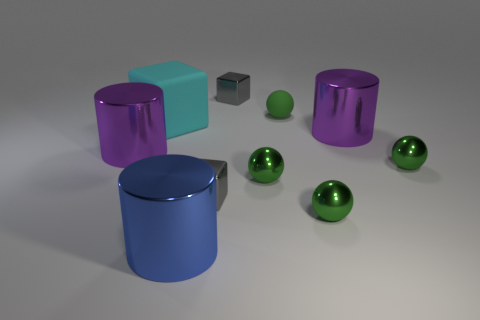How many other things are there of the same color as the tiny rubber object?
Provide a short and direct response. 3. There is a metal thing that is behind the small rubber ball; what is its color?
Provide a succinct answer. Gray. How big is the cylinder that is behind the blue metallic object and on the left side of the green rubber ball?
Make the answer very short. Large. Does the big cyan object have the same material as the tiny gray cube behind the cyan thing?
Keep it short and to the point. No. What number of small gray things are the same shape as the cyan object?
Give a very brief answer. 2. What number of tiny gray objects are there?
Ensure brevity in your answer.  2. Do the cyan object and the small green matte thing behind the large cyan object have the same shape?
Your answer should be compact. No. How many objects are either big purple metal objects or blocks in front of the big cyan block?
Provide a succinct answer. 3. Does the large thing that is left of the large rubber cube have the same shape as the large matte thing?
Your answer should be very brief. No. Is the number of blocks in front of the blue cylinder less than the number of metallic cylinders that are behind the large cyan matte cube?
Your answer should be very brief. No. 